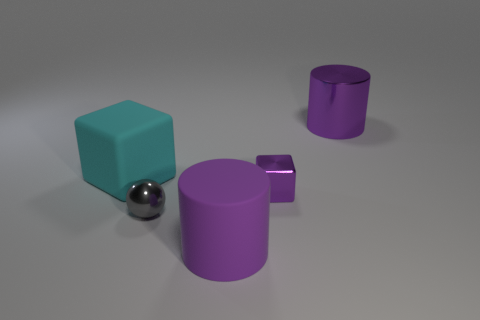Add 2 tiny gray metal cubes. How many objects exist? 7 Subtract all cylinders. How many objects are left? 3 Add 2 small purple metallic things. How many small purple metallic things are left? 3 Add 4 big yellow balls. How many big yellow balls exist? 4 Subtract 0 blue spheres. How many objects are left? 5 Subtract all large brown shiny blocks. Subtract all shiny cylinders. How many objects are left? 4 